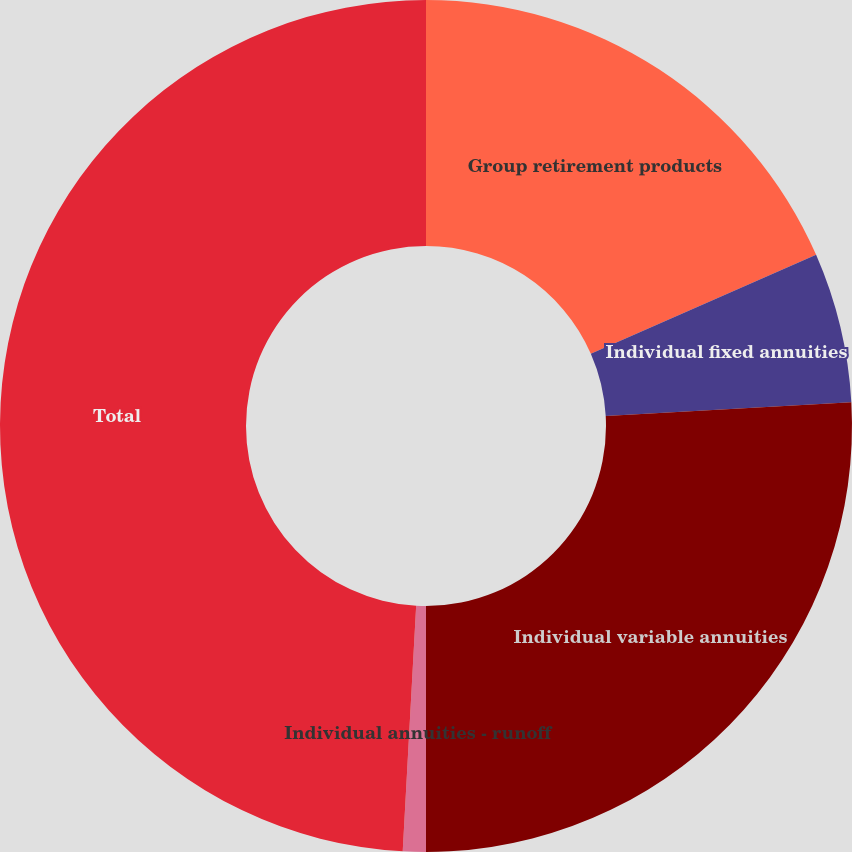Convert chart to OTSL. <chart><loc_0><loc_0><loc_500><loc_500><pie_chart><fcel>Group retirement products<fcel>Individual fixed annuities<fcel>Individual variable annuities<fcel>Individual annuities - runoff<fcel>Total<nl><fcel>18.42%<fcel>5.69%<fcel>25.89%<fcel>0.87%<fcel>49.13%<nl></chart> 